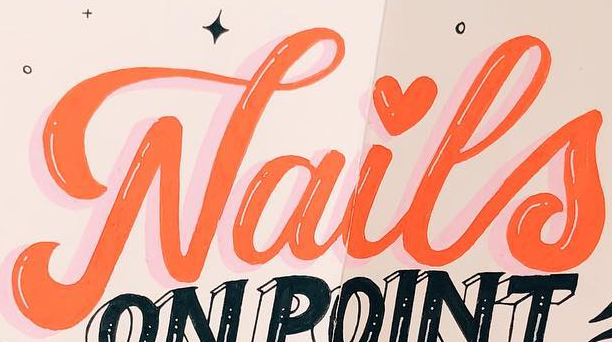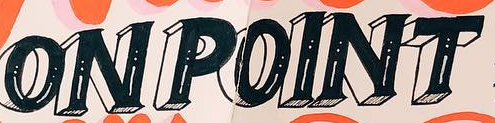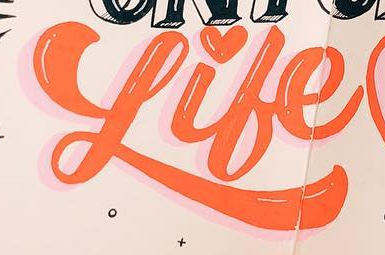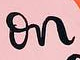Transcribe the words shown in these images in order, separated by a semicolon. Nails; ONPOINT; Like; on 